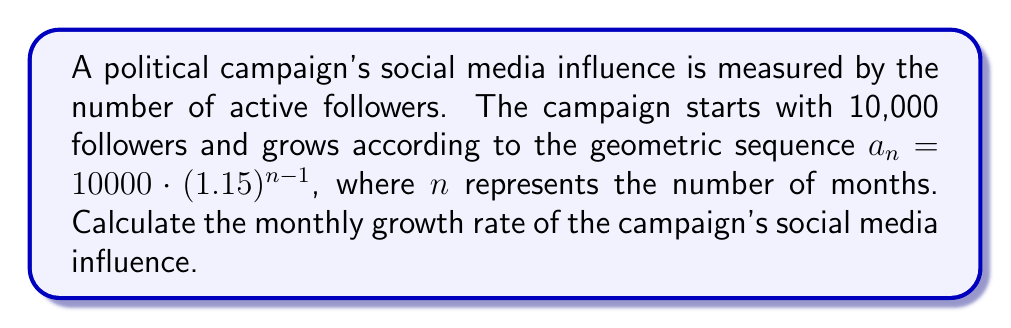Can you answer this question? To find the monthly growth rate, we need to analyze the given geometric sequence:

1) The general form of a geometric sequence is $a_n = a_1 \cdot r^{n-1}$, where $a_1$ is the first term and $r$ is the common ratio.

2) In our sequence, $a_n = 10000 \cdot (1.15)^{n-1}$

3) Comparing this to the general form, we can see that:
   $a_1 = 10000$
   $r = 1.15$

4) The common ratio $r$ represents the factor by which each term increases from the previous term.

5) To convert this to a percentage growth rate, we subtract 1 from $r$ and multiply by 100:

   Growth rate = $(r - 1) \times 100\%$
                = $(1.15 - 1) \times 100\%$
                = $0.15 \times 100\%$
                = $15\%$

Therefore, the monthly growth rate of the campaign's social media influence is 15%.
Answer: 15% 